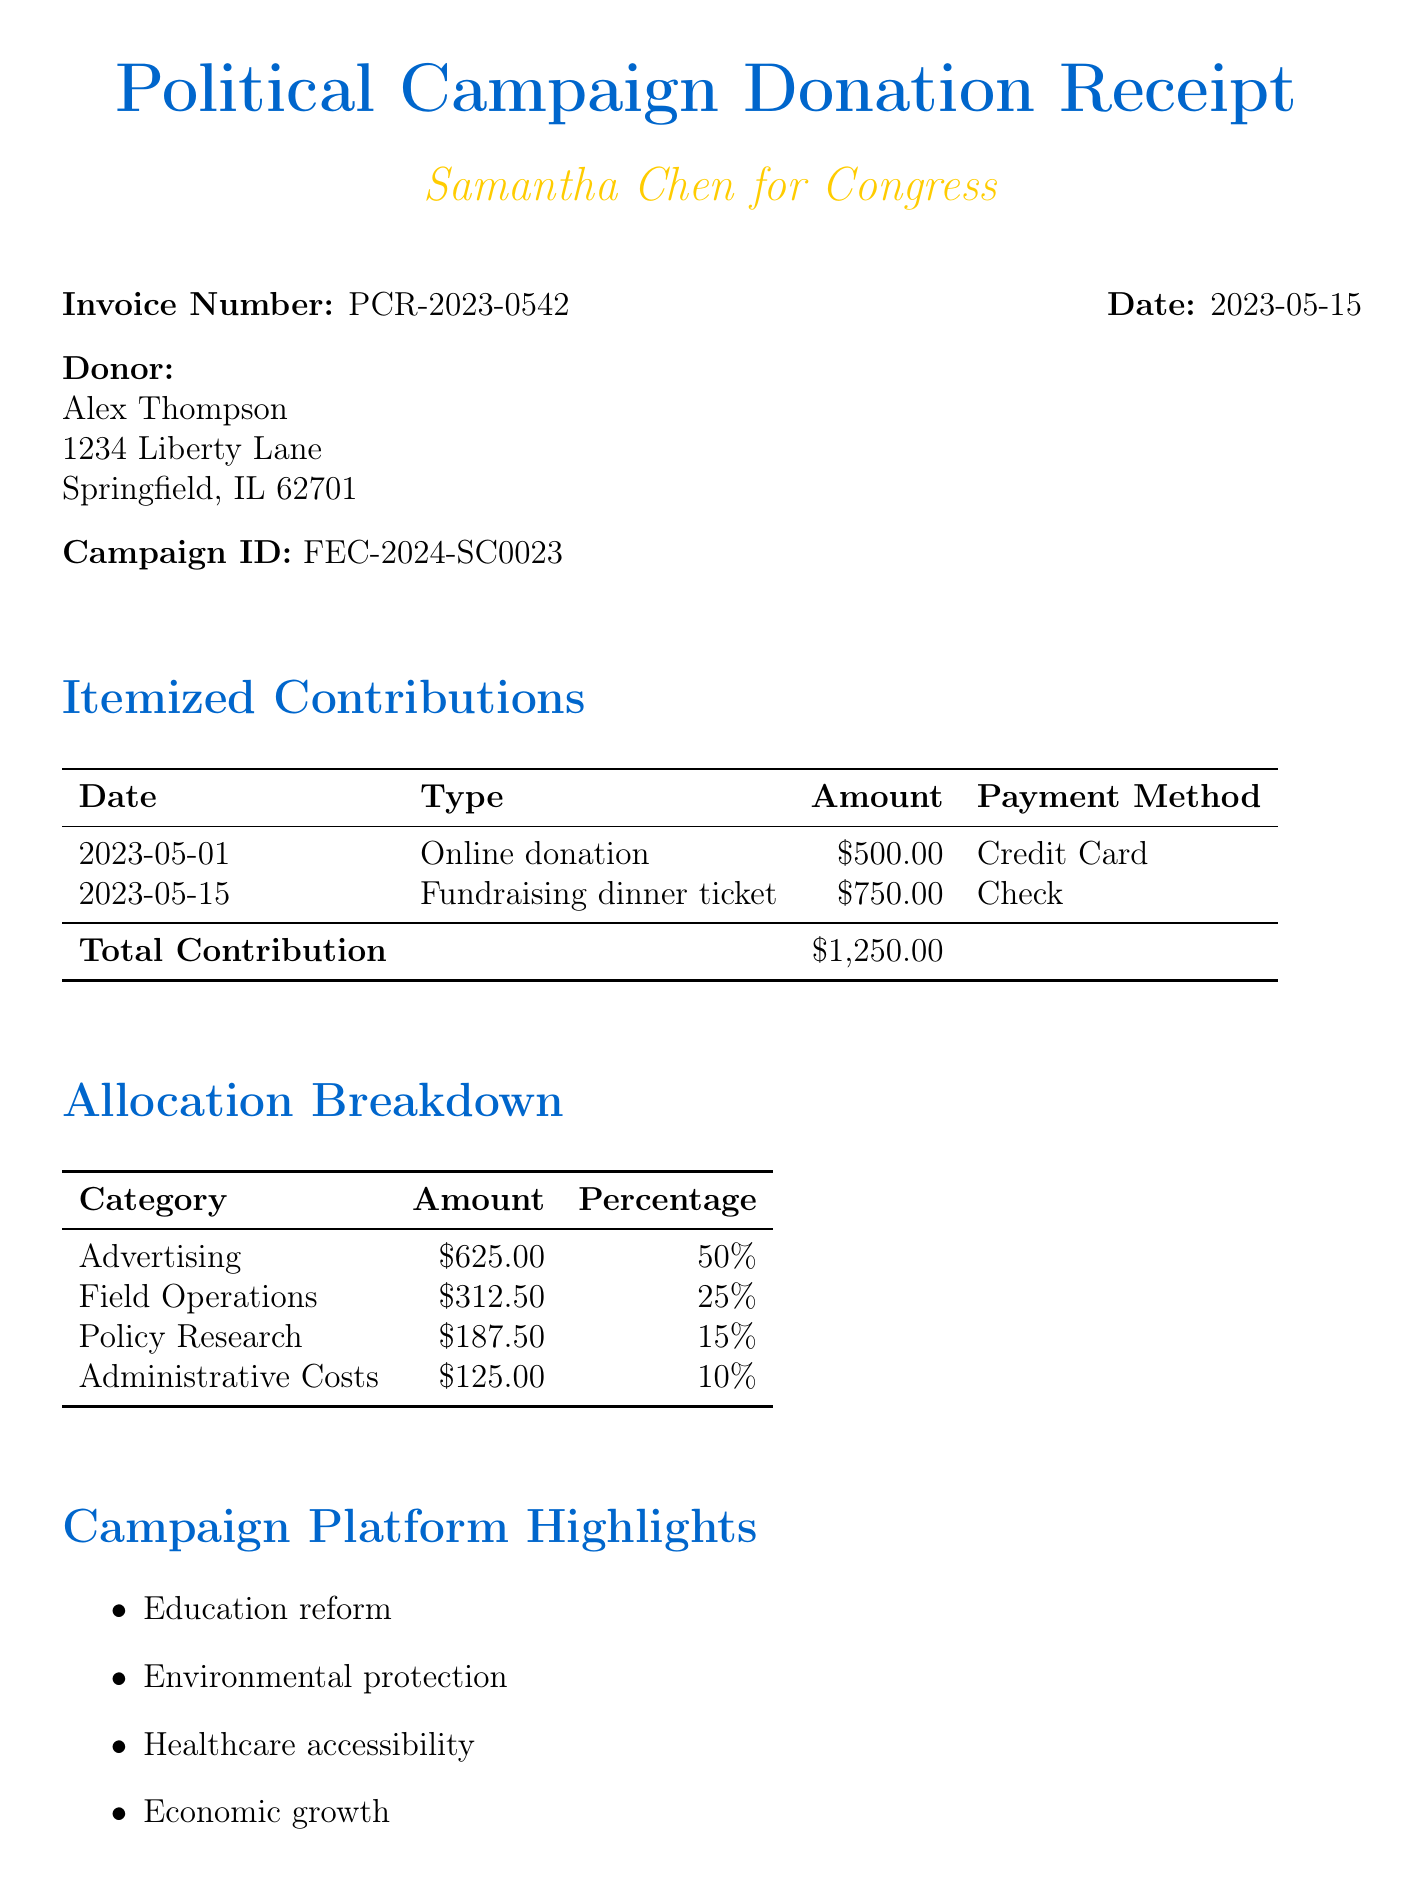What is the invoice number? The invoice number is listed prominently at the top of the document under "Invoice Number."
Answer: PCR-2023-0542 Who is the donor? The donor's name is provided in the "Donor" section of the document.
Answer: Alex Thompson What was the date of the online donation? The date of the online donation is part of the itemized contributions, listed under "Date."
Answer: 2023-05-01 How much was allocated to field operations? The allocation breakdown section specifies the amount allocated to field operations.
Answer: 312.50 What payment method was used for the fundraising dinner ticket? The payment method for the fundraising dinner ticket is included in the itemized contributions.
Answer: Check Which campaign platform highlight relates to the environment? The campaign platform highlights each mention different areas, including the environment.
Answer: Environmental protection What percentage of the total contribution was allocated to advertising? The percentage allocated to advertising is noted in the allocation breakdown table.
Answer: 50 What is the total contribution amount? The total contribution amount is explicitly stated in the itemized contributions table.
Answer: 1250.00 Who is the campaign treasurer? The treasurer's name is mentioned toward the end of the document.
Answer: Michael Rodriguez 